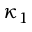<formula> <loc_0><loc_0><loc_500><loc_500>\kappa _ { 1 }</formula> 